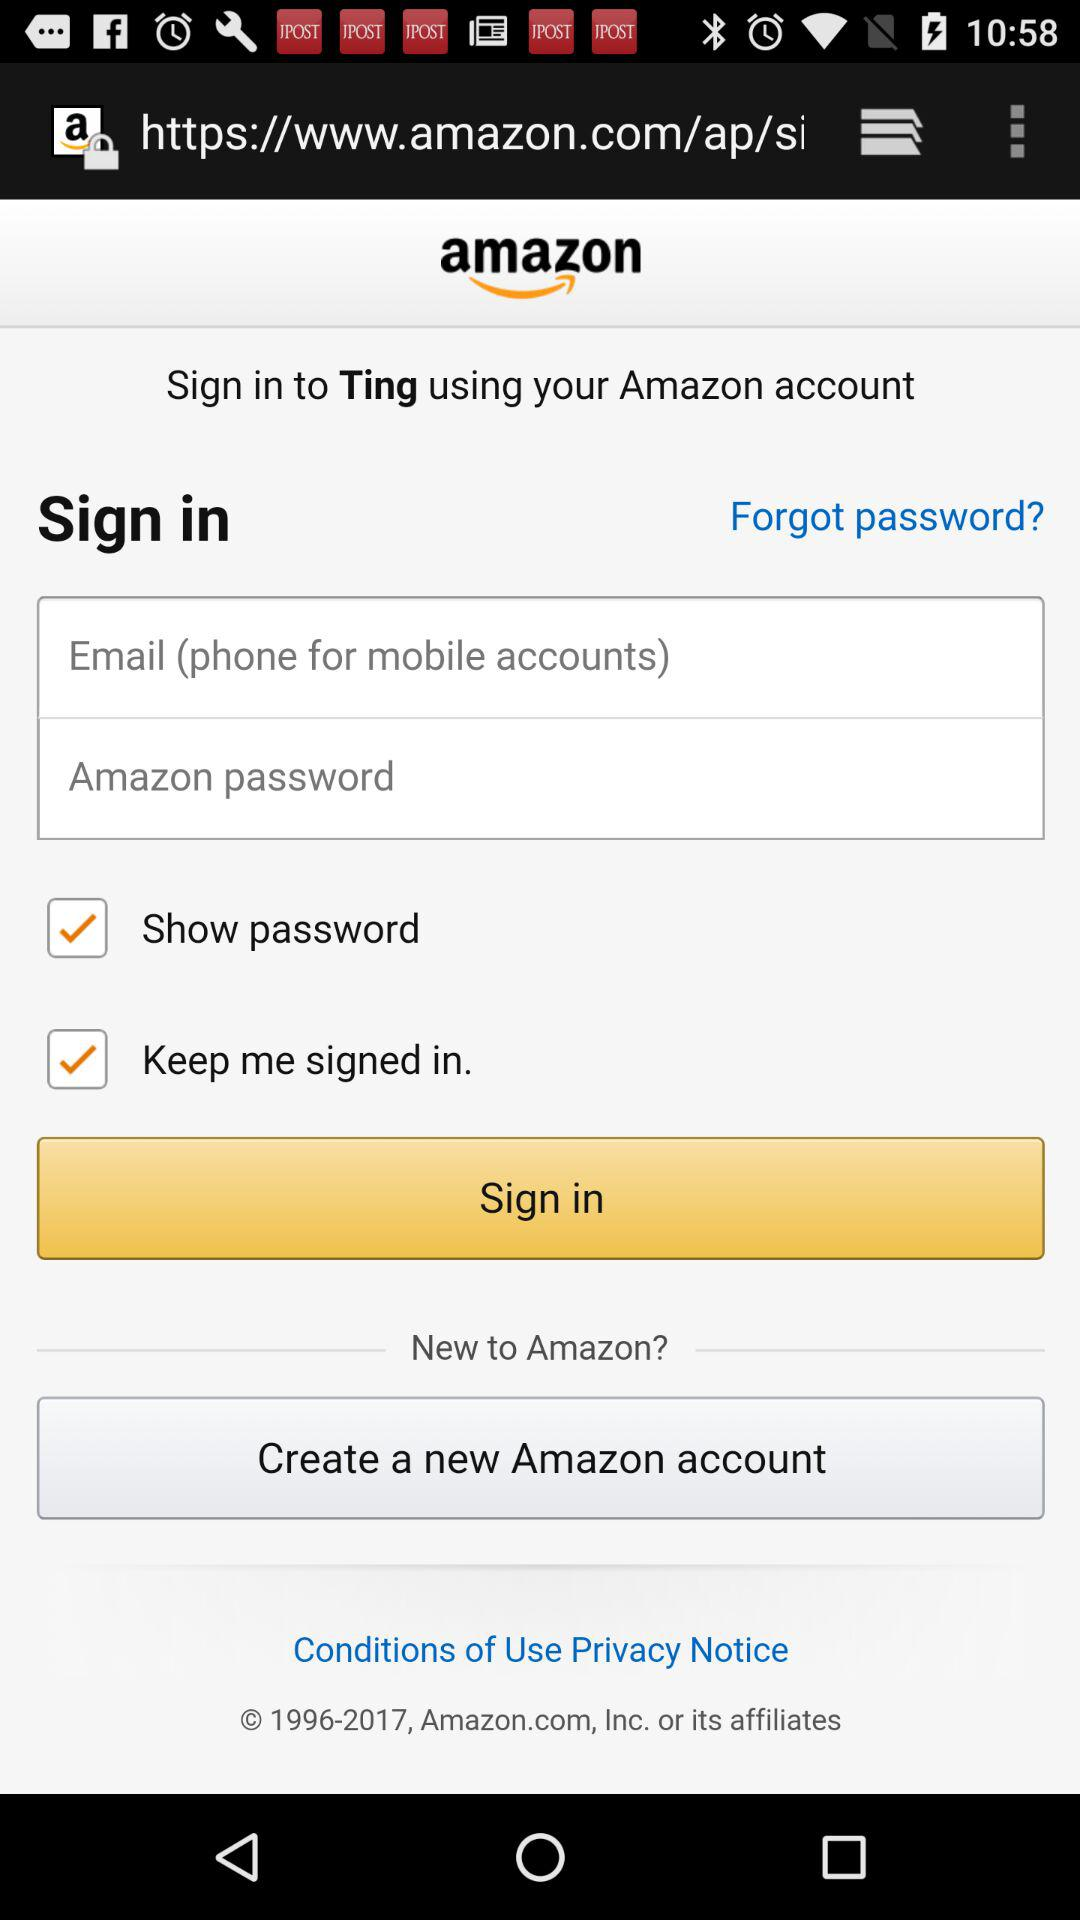To what application can we sign in? You can sign in to "Ting" application. 